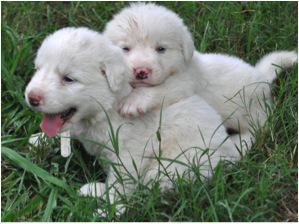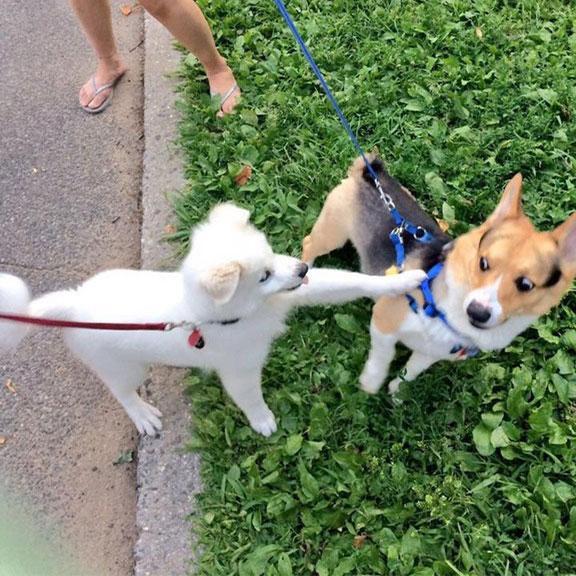The first image is the image on the left, the second image is the image on the right. For the images displayed, is the sentence "In at least one image there are exactly two dogs." factually correct? Answer yes or no. Yes. The first image is the image on the left, the second image is the image on the right. Examine the images to the left and right. Is the description "At least one of the images is of two dogs." accurate? Answer yes or no. Yes. 